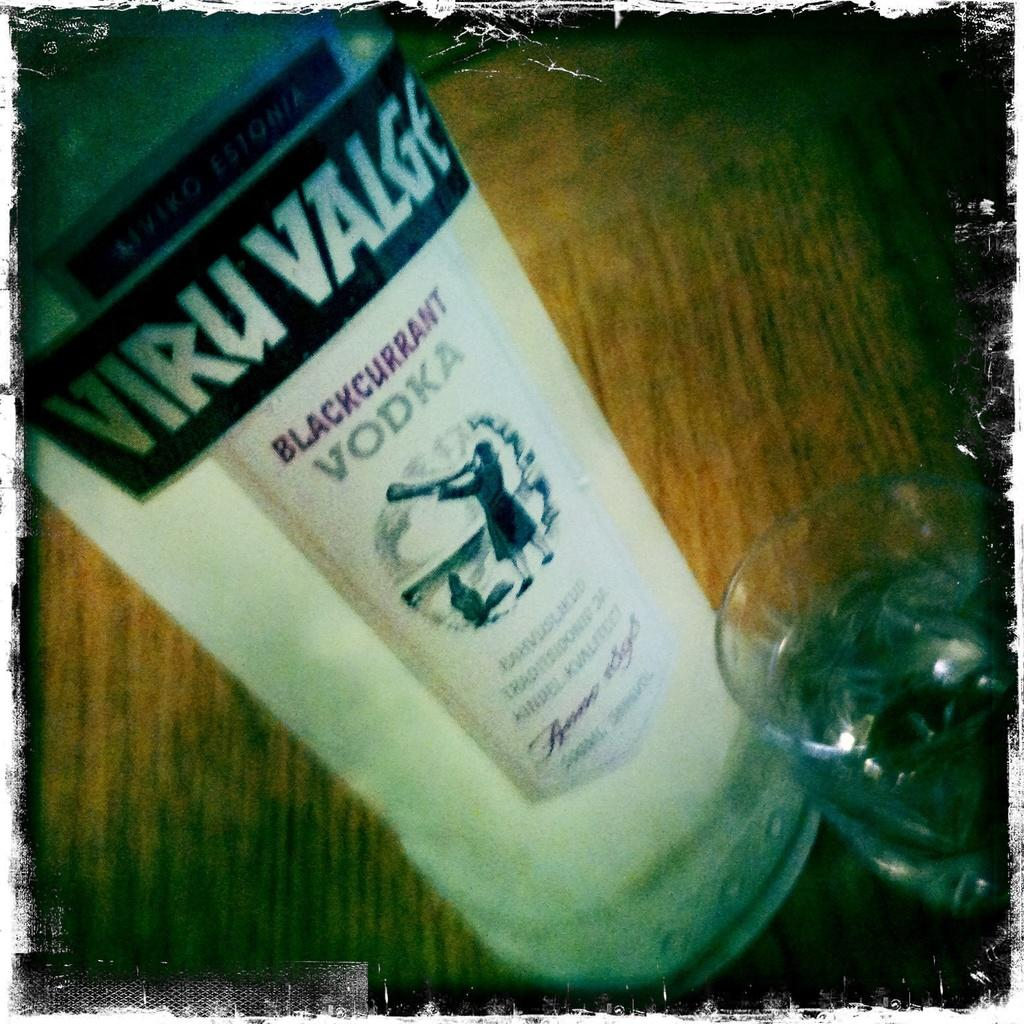<image>
Offer a succinct explanation of the picture presented. A bottle of Viru Valge vodka sitting on a table. 